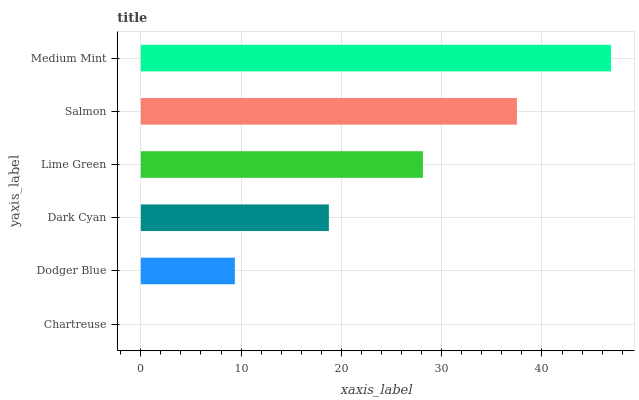Is Chartreuse the minimum?
Answer yes or no. Yes. Is Medium Mint the maximum?
Answer yes or no. Yes. Is Dodger Blue the minimum?
Answer yes or no. No. Is Dodger Blue the maximum?
Answer yes or no. No. Is Dodger Blue greater than Chartreuse?
Answer yes or no. Yes. Is Chartreuse less than Dodger Blue?
Answer yes or no. Yes. Is Chartreuse greater than Dodger Blue?
Answer yes or no. No. Is Dodger Blue less than Chartreuse?
Answer yes or no. No. Is Lime Green the high median?
Answer yes or no. Yes. Is Dark Cyan the low median?
Answer yes or no. Yes. Is Salmon the high median?
Answer yes or no. No. Is Salmon the low median?
Answer yes or no. No. 